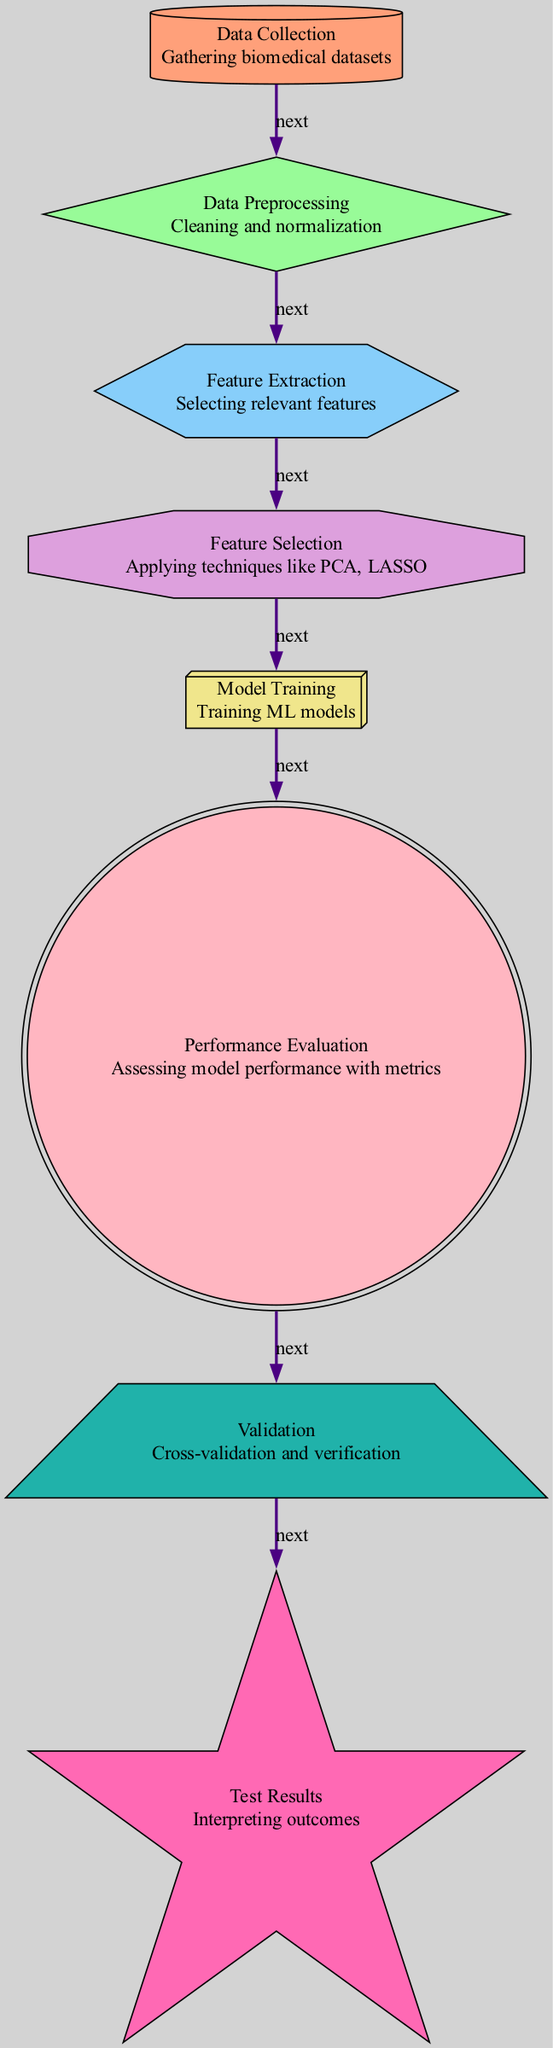What is the first step in the diagram? The first step in the diagram is represented by the "Data Collection" node, which indicates that the process begins with gathering biomedical datasets.
Answer: Data Collection How many nodes are present in the diagram? By counting all the individual nodes listed, we find there are eight nodes in total, representing various stages of the machine learning process.
Answer: Eight What technique is applied in the "Feature Selection" step? The "Feature Selection" node specifies that techniques like PCA and LASSO are applied, which are common methods for selecting relevant features.
Answer: PCA, LASSO What is the final step before interpreting outcomes? The last step before interpreting outcomes is "Validation," which involves cross-validation and verification of the model before the final interpretation of results.
Answer: Validation Which node describes the cleaning and normalization process? The "Data Preprocessing" node explicitly describes the cleaning and normalization process as a crucial part of preparing data for analysis.
Answer: Data Preprocessing What is the role of the "Performance Evaluation" node in the flow? The "Performance Evaluation" node assesses the model's performance using various metrics, serving as a key step in measuring success.
Answer: Assessing model performance How many edges connect the nodes in the diagram? There are seven edges connecting the nodes, showing the flow from one step to another throughout the machine learning process.
Answer: Seven What shape represents the "Feature Extraction" process? The "Feature Extraction" process is represented by a hexagon shape, as specified in the diagram's design.
Answer: Hexagon Which step comes directly after "Model Training"? "Performance Evaluation" directly follows "Model Training" in the sequence, indicating that evaluation happens immediately after training the model.
Answer: Performance Evaluation 